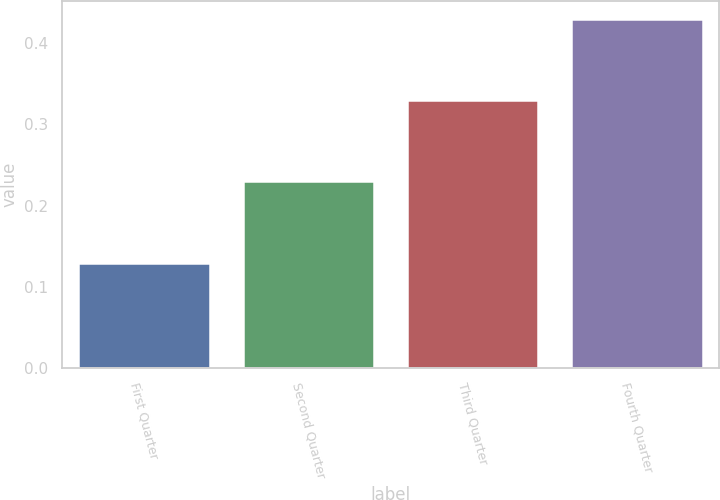Convert chart. <chart><loc_0><loc_0><loc_500><loc_500><bar_chart><fcel>First Quarter<fcel>Second Quarter<fcel>Third Quarter<fcel>Fourth Quarter<nl><fcel>0.13<fcel>0.23<fcel>0.33<fcel>0.43<nl></chart> 